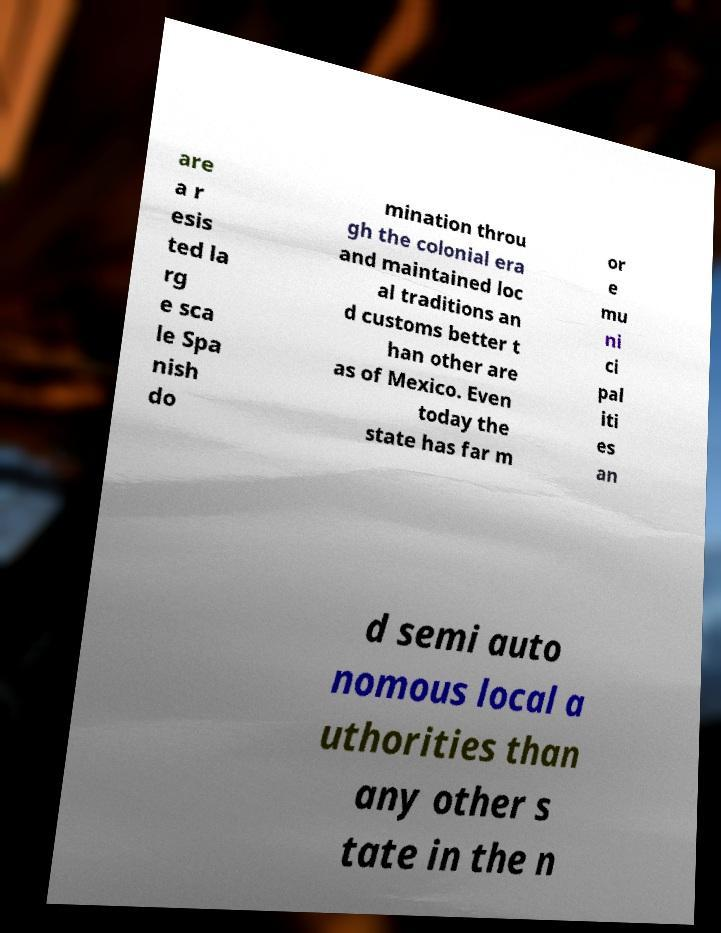There's text embedded in this image that I need extracted. Can you transcribe it verbatim? are a r esis ted la rg e sca le Spa nish do mination throu gh the colonial era and maintained loc al traditions an d customs better t han other are as of Mexico. Even today the state has far m or e mu ni ci pal iti es an d semi auto nomous local a uthorities than any other s tate in the n 